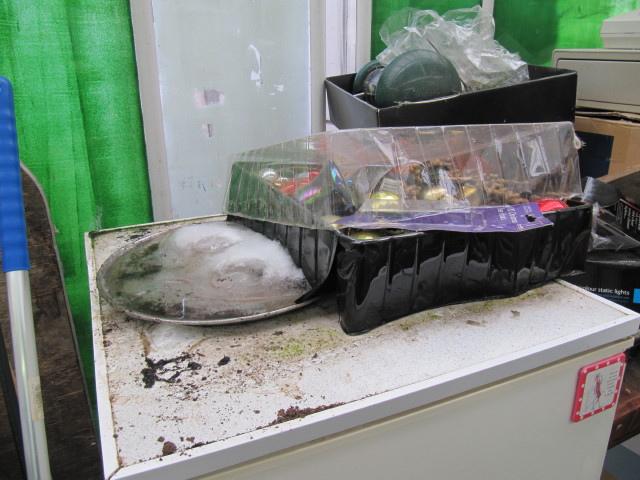Is the freezer dirty?
Keep it brief. Yes. What color are the curtains?
Answer briefly. Green. Why is the top of the appliance so dirty?
Write a very short answer. It's outside. 